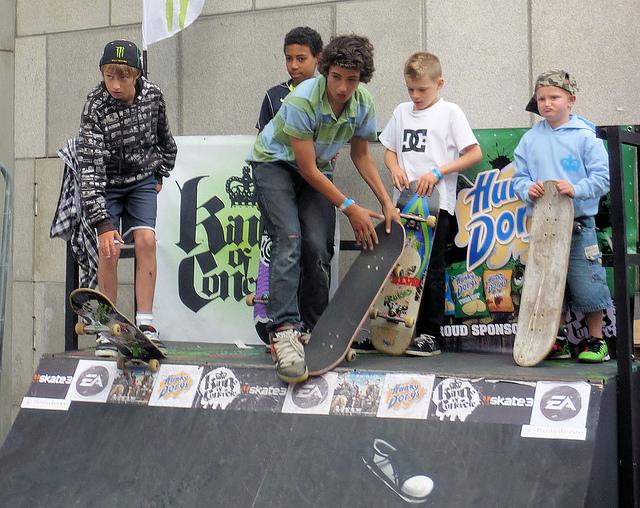Are there ads behind the skaters?
Give a very brief answer. Yes. What are the kids skating on?
Write a very short answer. Ramp. How many skateboards are visible?
Concise answer only. 4. 